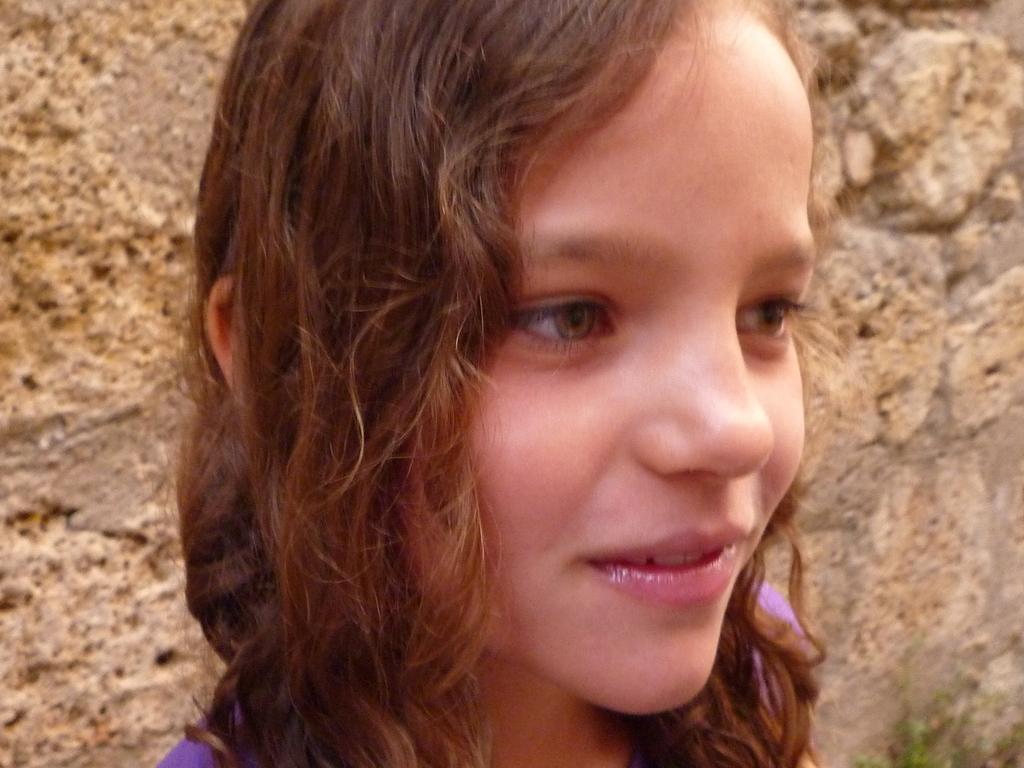Could you give a brief overview of what you see in this image? In this image there is a girl, in the background there is a wall. 